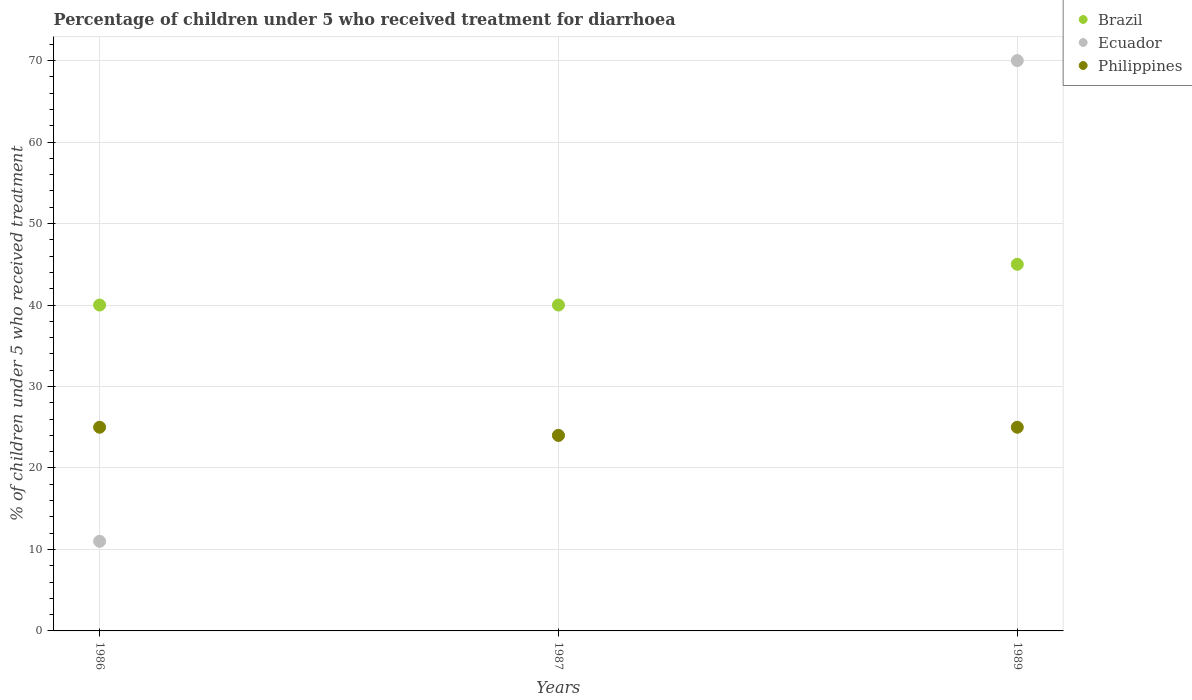How many different coloured dotlines are there?
Give a very brief answer. 3. Across all years, what is the maximum percentage of children who received treatment for diarrhoea  in Philippines?
Give a very brief answer. 25. In which year was the percentage of children who received treatment for diarrhoea  in Philippines maximum?
Ensure brevity in your answer.  1986. In which year was the percentage of children who received treatment for diarrhoea  in Brazil minimum?
Your answer should be very brief. 1986. What is the total percentage of children who received treatment for diarrhoea  in Ecuador in the graph?
Make the answer very short. 105. What is the difference between the percentage of children who received treatment for diarrhoea  in Ecuador in 1987 and that in 1989?
Give a very brief answer. -46. What is the difference between the percentage of children who received treatment for diarrhoea  in Ecuador in 1986 and the percentage of children who received treatment for diarrhoea  in Brazil in 1987?
Make the answer very short. -29. In how many years, is the percentage of children who received treatment for diarrhoea  in Ecuador greater than 36 %?
Provide a succinct answer. 1. What is the ratio of the percentage of children who received treatment for diarrhoea  in Ecuador in 1987 to that in 1989?
Provide a short and direct response. 0.34. Is the percentage of children who received treatment for diarrhoea  in Ecuador in 1986 less than that in 1987?
Your answer should be very brief. Yes. What is the difference between the highest and the lowest percentage of children who received treatment for diarrhoea  in Philippines?
Provide a succinct answer. 1. In how many years, is the percentage of children who received treatment for diarrhoea  in Brazil greater than the average percentage of children who received treatment for diarrhoea  in Brazil taken over all years?
Offer a very short reply. 1. Is the sum of the percentage of children who received treatment for diarrhoea  in Ecuador in 1986 and 1989 greater than the maximum percentage of children who received treatment for diarrhoea  in Brazil across all years?
Your answer should be very brief. Yes. Is it the case that in every year, the sum of the percentage of children who received treatment for diarrhoea  in Philippines and percentage of children who received treatment for diarrhoea  in Ecuador  is greater than the percentage of children who received treatment for diarrhoea  in Brazil?
Provide a short and direct response. No. Does the percentage of children who received treatment for diarrhoea  in Brazil monotonically increase over the years?
Ensure brevity in your answer.  No. How many dotlines are there?
Make the answer very short. 3. Does the graph contain any zero values?
Your answer should be very brief. No. Where does the legend appear in the graph?
Keep it short and to the point. Top right. How are the legend labels stacked?
Offer a terse response. Vertical. What is the title of the graph?
Your answer should be very brief. Percentage of children under 5 who received treatment for diarrhoea. What is the label or title of the Y-axis?
Offer a very short reply. % of children under 5 who received treatment. What is the % of children under 5 who received treatment of Ecuador in 1986?
Your response must be concise. 11. What is the % of children under 5 who received treatment in Brazil in 1989?
Provide a short and direct response. 45. Across all years, what is the maximum % of children under 5 who received treatment in Ecuador?
Your response must be concise. 70. What is the total % of children under 5 who received treatment in Brazil in the graph?
Ensure brevity in your answer.  125. What is the total % of children under 5 who received treatment of Ecuador in the graph?
Provide a succinct answer. 105. What is the difference between the % of children under 5 who received treatment of Brazil in 1986 and that in 1987?
Give a very brief answer. 0. What is the difference between the % of children under 5 who received treatment in Philippines in 1986 and that in 1987?
Your answer should be very brief. 1. What is the difference between the % of children under 5 who received treatment of Ecuador in 1986 and that in 1989?
Your answer should be compact. -59. What is the difference between the % of children under 5 who received treatment of Brazil in 1987 and that in 1989?
Keep it short and to the point. -5. What is the difference between the % of children under 5 who received treatment of Ecuador in 1987 and that in 1989?
Your answer should be compact. -46. What is the difference between the % of children under 5 who received treatment in Brazil in 1986 and the % of children under 5 who received treatment in Philippines in 1989?
Make the answer very short. 15. What is the difference between the % of children under 5 who received treatment in Ecuador in 1987 and the % of children under 5 who received treatment in Philippines in 1989?
Give a very brief answer. -1. What is the average % of children under 5 who received treatment of Brazil per year?
Your answer should be compact. 41.67. What is the average % of children under 5 who received treatment of Ecuador per year?
Provide a succinct answer. 35. What is the average % of children under 5 who received treatment of Philippines per year?
Provide a succinct answer. 24.67. In the year 1986, what is the difference between the % of children under 5 who received treatment of Brazil and % of children under 5 who received treatment of Philippines?
Your response must be concise. 15. In the year 1989, what is the difference between the % of children under 5 who received treatment in Brazil and % of children under 5 who received treatment in Ecuador?
Give a very brief answer. -25. What is the ratio of the % of children under 5 who received treatment in Brazil in 1986 to that in 1987?
Make the answer very short. 1. What is the ratio of the % of children under 5 who received treatment of Ecuador in 1986 to that in 1987?
Offer a very short reply. 0.46. What is the ratio of the % of children under 5 who received treatment in Philippines in 1986 to that in 1987?
Give a very brief answer. 1.04. What is the ratio of the % of children under 5 who received treatment in Ecuador in 1986 to that in 1989?
Your answer should be very brief. 0.16. What is the ratio of the % of children under 5 who received treatment in Brazil in 1987 to that in 1989?
Your answer should be compact. 0.89. What is the ratio of the % of children under 5 who received treatment of Ecuador in 1987 to that in 1989?
Provide a short and direct response. 0.34. What is the difference between the highest and the second highest % of children under 5 who received treatment of Brazil?
Provide a succinct answer. 5. What is the difference between the highest and the second highest % of children under 5 who received treatment of Philippines?
Your answer should be very brief. 0. What is the difference between the highest and the lowest % of children under 5 who received treatment of Ecuador?
Make the answer very short. 59. What is the difference between the highest and the lowest % of children under 5 who received treatment of Philippines?
Offer a very short reply. 1. 